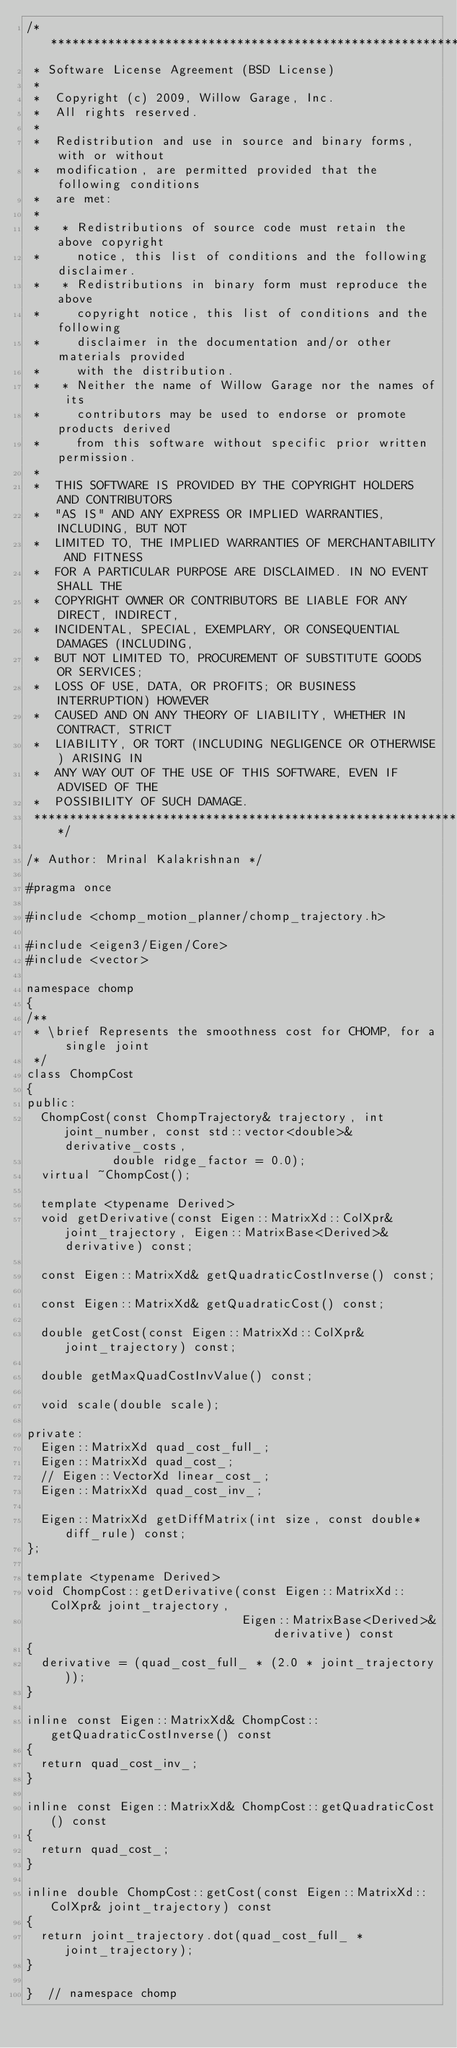Convert code to text. <code><loc_0><loc_0><loc_500><loc_500><_C_>/*********************************************************************
 * Software License Agreement (BSD License)
 *
 *  Copyright (c) 2009, Willow Garage, Inc.
 *  All rights reserved.
 *
 *  Redistribution and use in source and binary forms, with or without
 *  modification, are permitted provided that the following conditions
 *  are met:
 *
 *   * Redistributions of source code must retain the above copyright
 *     notice, this list of conditions and the following disclaimer.
 *   * Redistributions in binary form must reproduce the above
 *     copyright notice, this list of conditions and the following
 *     disclaimer in the documentation and/or other materials provided
 *     with the distribution.
 *   * Neither the name of Willow Garage nor the names of its
 *     contributors may be used to endorse or promote products derived
 *     from this software without specific prior written permission.
 *
 *  THIS SOFTWARE IS PROVIDED BY THE COPYRIGHT HOLDERS AND CONTRIBUTORS
 *  "AS IS" AND ANY EXPRESS OR IMPLIED WARRANTIES, INCLUDING, BUT NOT
 *  LIMITED TO, THE IMPLIED WARRANTIES OF MERCHANTABILITY AND FITNESS
 *  FOR A PARTICULAR PURPOSE ARE DISCLAIMED. IN NO EVENT SHALL THE
 *  COPYRIGHT OWNER OR CONTRIBUTORS BE LIABLE FOR ANY DIRECT, INDIRECT,
 *  INCIDENTAL, SPECIAL, EXEMPLARY, OR CONSEQUENTIAL DAMAGES (INCLUDING,
 *  BUT NOT LIMITED TO, PROCUREMENT OF SUBSTITUTE GOODS OR SERVICES;
 *  LOSS OF USE, DATA, OR PROFITS; OR BUSINESS INTERRUPTION) HOWEVER
 *  CAUSED AND ON ANY THEORY OF LIABILITY, WHETHER IN CONTRACT, STRICT
 *  LIABILITY, OR TORT (INCLUDING NEGLIGENCE OR OTHERWISE) ARISING IN
 *  ANY WAY OUT OF THE USE OF THIS SOFTWARE, EVEN IF ADVISED OF THE
 *  POSSIBILITY OF SUCH DAMAGE.
 *********************************************************************/

/* Author: Mrinal Kalakrishnan */

#pragma once

#include <chomp_motion_planner/chomp_trajectory.h>

#include <eigen3/Eigen/Core>
#include <vector>

namespace chomp
{
/**
 * \brief Represents the smoothness cost for CHOMP, for a single joint
 */
class ChompCost
{
public:
  ChompCost(const ChompTrajectory& trajectory, int joint_number, const std::vector<double>& derivative_costs,
            double ridge_factor = 0.0);
  virtual ~ChompCost();

  template <typename Derived>
  void getDerivative(const Eigen::MatrixXd::ColXpr& joint_trajectory, Eigen::MatrixBase<Derived>& derivative) const;

  const Eigen::MatrixXd& getQuadraticCostInverse() const;

  const Eigen::MatrixXd& getQuadraticCost() const;

  double getCost(const Eigen::MatrixXd::ColXpr& joint_trajectory) const;

  double getMaxQuadCostInvValue() const;

  void scale(double scale);

private:
  Eigen::MatrixXd quad_cost_full_;
  Eigen::MatrixXd quad_cost_;
  // Eigen::VectorXd linear_cost_;
  Eigen::MatrixXd quad_cost_inv_;

  Eigen::MatrixXd getDiffMatrix(int size, const double* diff_rule) const;
};

template <typename Derived>
void ChompCost::getDerivative(const Eigen::MatrixXd::ColXpr& joint_trajectory,
                              Eigen::MatrixBase<Derived>& derivative) const
{
  derivative = (quad_cost_full_ * (2.0 * joint_trajectory));
}

inline const Eigen::MatrixXd& ChompCost::getQuadraticCostInverse() const
{
  return quad_cost_inv_;
}

inline const Eigen::MatrixXd& ChompCost::getQuadraticCost() const
{
  return quad_cost_;
}

inline double ChompCost::getCost(const Eigen::MatrixXd::ColXpr& joint_trajectory) const
{
  return joint_trajectory.dot(quad_cost_full_ * joint_trajectory);
}

}  // namespace chomp
</code> 